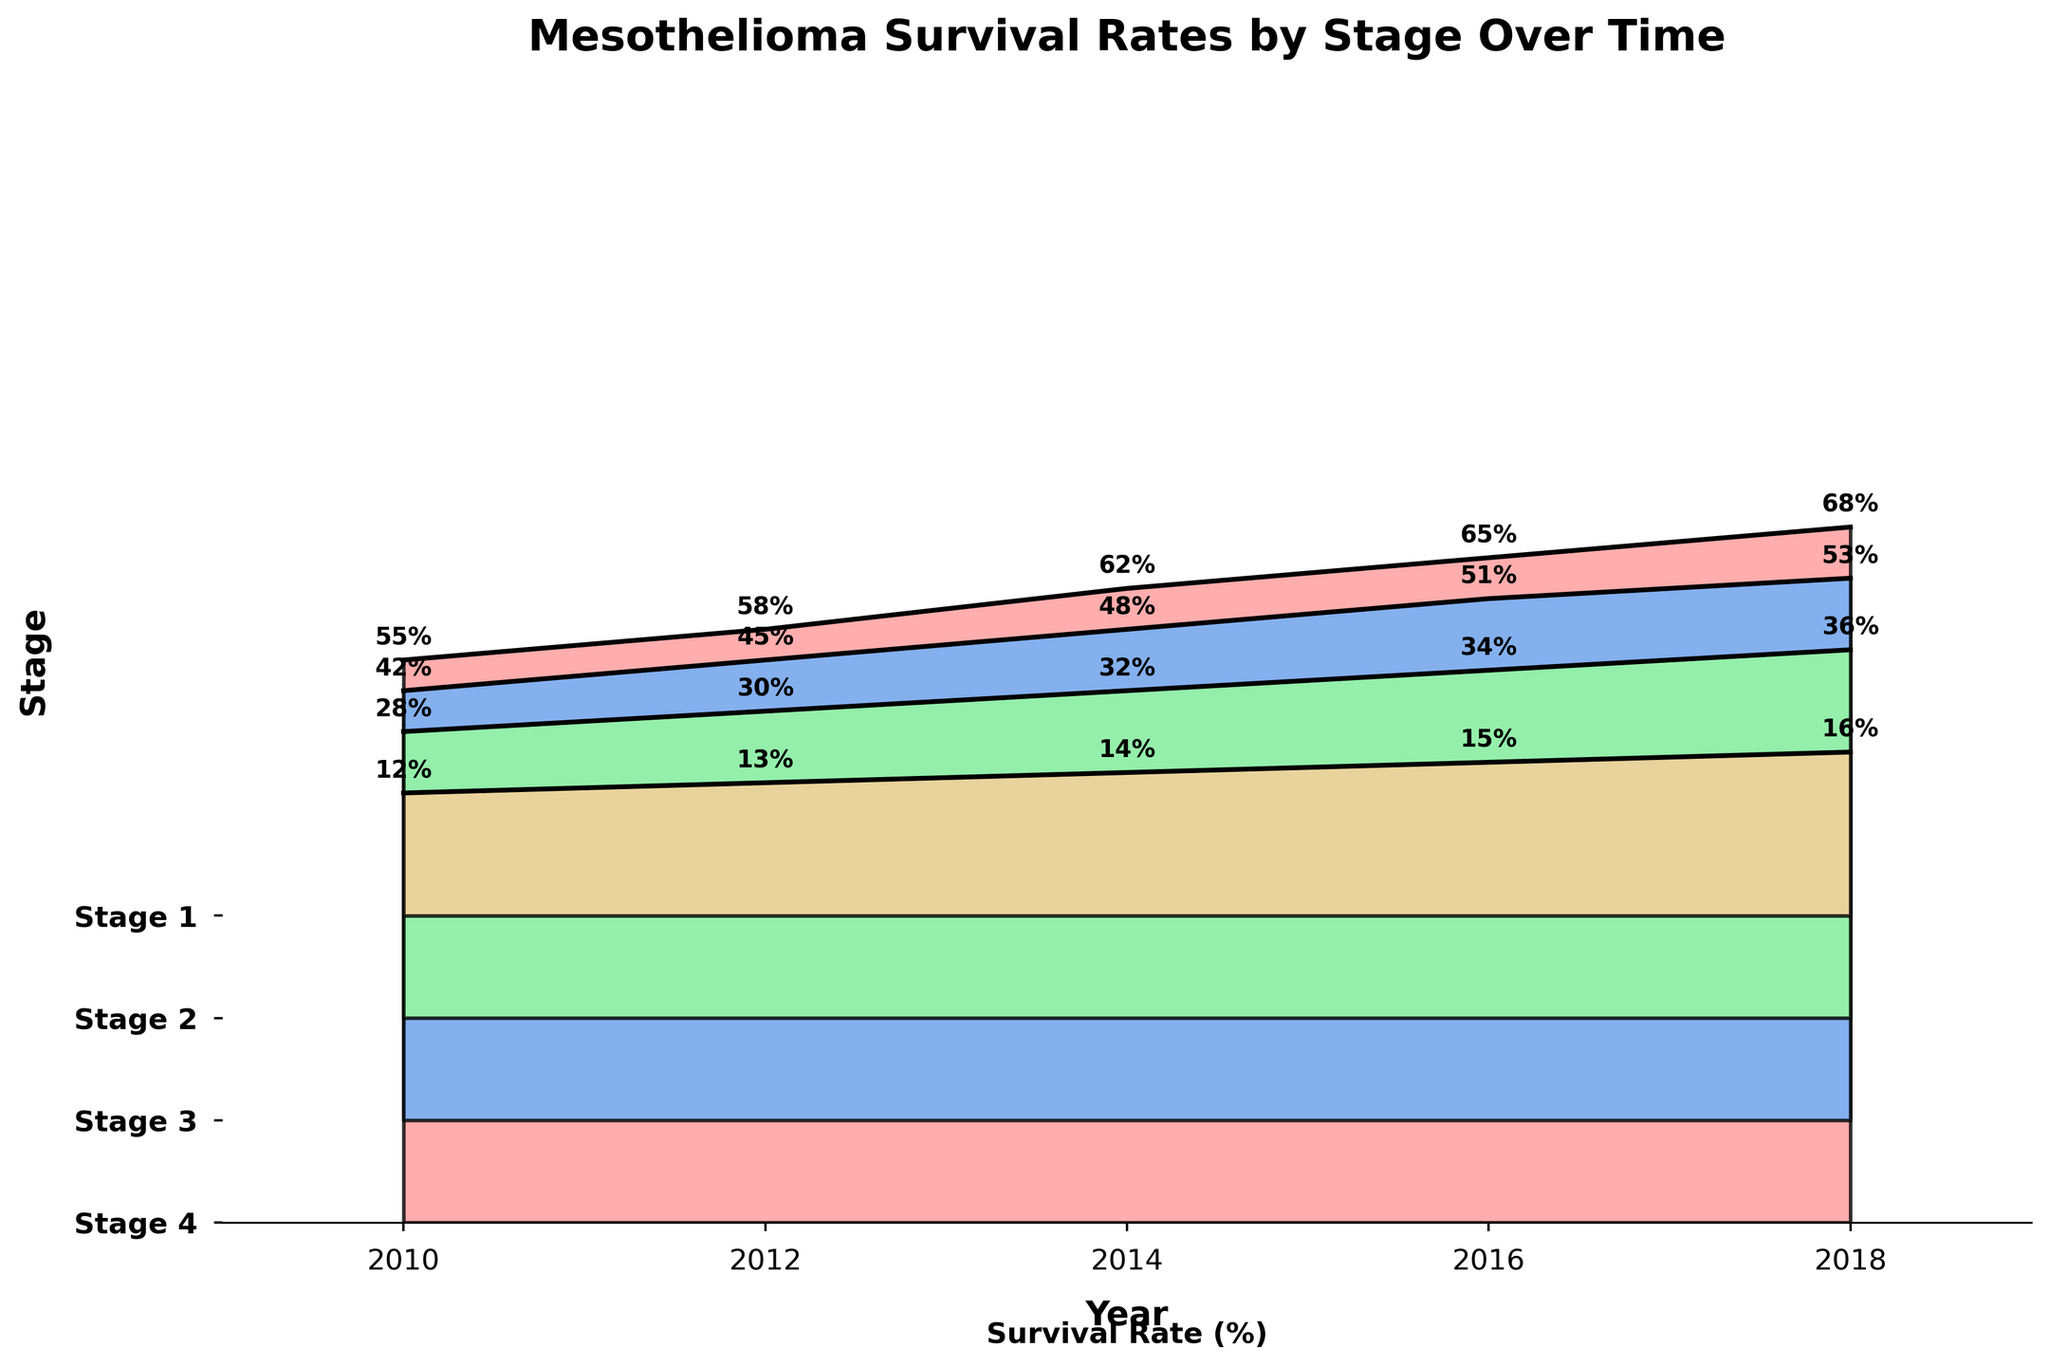What is the title of the figure? The title of the figure can be found at the top and provides a summary of what the figure is about. From the profile, we know it is "Mesothelioma Survival Rates by Stage Over Time".
Answer: Mesothelioma Survival Rates by Stage Over Time How many treatment stages are shown in the figure? The figure displays distinct areas filled with different colors corresponding to different treatment stages. There are four areas with labels: Stage 1, Stage 2, Stage 3, and Stage 4.
Answer: 4 Is the survival rate higher in 2018 compared to 2010 for Stage 2? By looking at the y-values for Stage 2 above the years 2010 and 2018, it is clear that the survival rate is lower in 2010 (42%) compared to 2018 (53%).
Answer: Yes Which stage exhibits the highest survival rate in 2010? For 2010, compare the y-values of all stages. Stage 1 has the highest survival rate at 55%.
Answer: Stage 1 What is the difference in survival rates from 2010 to 2018 for Stage 3? For Stage 3, the survival rate in 2010 is 28% and in 2018 it is 36%. The difference is 36% - 28% = 8%.
Answer: 8% Which year shows the highest survival rate for Stage 4? By comparing the y-values for Stage 4 across all the years, the highest value (16%) is found in 2018.
Answer: 2018 How do survival rates change over time for Stage 1? Observing the trend line and y-values of Stage 1 from 2010 (55%) to 2018 (68%), the rate consistently increases over time.
Answer: Increase Which stage has the smallest increase in survival rates from 2010 to 2018? Calculate the increase for all stages: Stage 1 (68%-55%=13%), Stage 2 (53%-42%=11%), Stage 3 (36%-28%=8%), and Stage 4 (16%-12%=4%). Stage 4 shows the smallest increase.
Answer: Stage 4 Between which two stages is there the largest difference in survival rates in 2014? Comparing the y-values for all stages in 2014: Stage 1 (62%), Stage 2 (48%), Stage 3 (32%), and Stage 4 (14%). The largest difference is between Stage 1 (62%) and Stage 4 (14%), which is 62% - 14% = 48%.
Answer: Stage 1 and Stage 4 